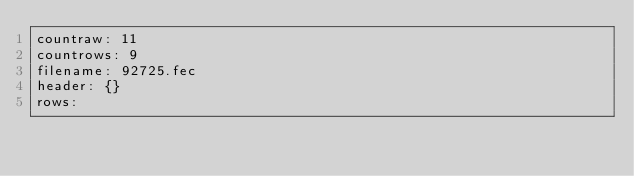Convert code to text. <code><loc_0><loc_0><loc_500><loc_500><_YAML_>countraw: 11
countrows: 9
filename: 92725.fec
header: {}
rows:</code> 